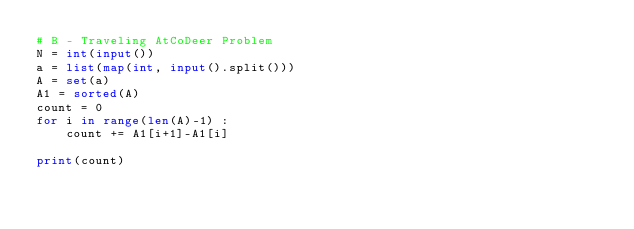<code> <loc_0><loc_0><loc_500><loc_500><_Python_># B - Traveling AtCoDeer Problem
N = int(input())
a = list(map(int, input().split()))
A = set(a)
A1 = sorted(A)
count = 0
for i in range(len(A)-1) :
    count += A1[i+1]-A1[i]

print(count)</code> 